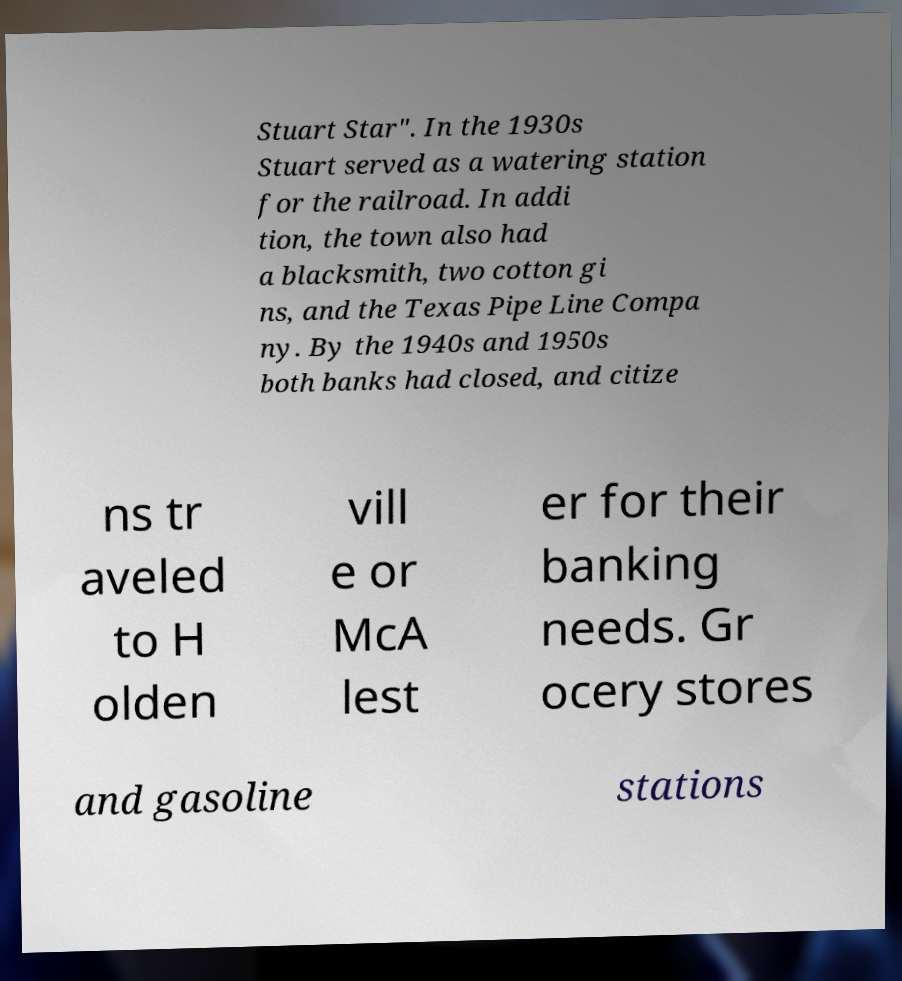What messages or text are displayed in this image? I need them in a readable, typed format. Stuart Star". In the 1930s Stuart served as a watering station for the railroad. In addi tion, the town also had a blacksmith, two cotton gi ns, and the Texas Pipe Line Compa ny. By the 1940s and 1950s both banks had closed, and citize ns tr aveled to H olden vill e or McA lest er for their banking needs. Gr ocery stores and gasoline stations 